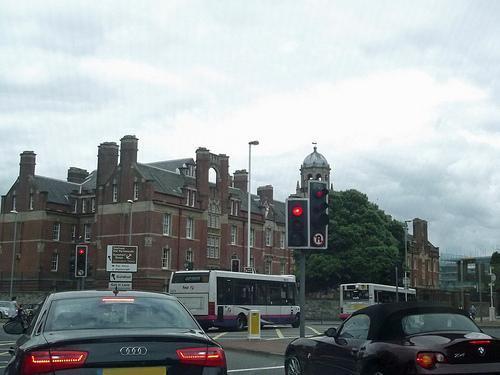How many busses are in this photo?
Give a very brief answer. 2. How many cars are in the picture?
Give a very brief answer. 2. 